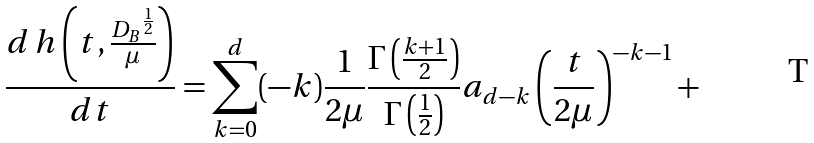<formula> <loc_0><loc_0><loc_500><loc_500>\frac { d \, h \left ( t , \frac { { D _ { B } } ^ { \frac { 1 } { 2 } } } { \mu } \right ) } { d t } = \sum _ { k = 0 } ^ { d } ( - k ) \frac { 1 } { 2 \mu } \frac { \Gamma \left ( \frac { k + 1 } 2 \right ) } { \Gamma \left ( \frac { 1 } { 2 } \right ) } a _ { d - k } \left ( \frac { t } { 2 \mu } \right ) ^ { - k - 1 } +</formula> 